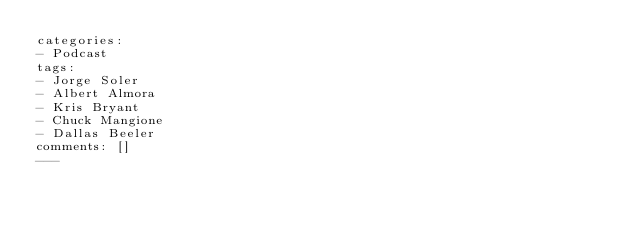<code> <loc_0><loc_0><loc_500><loc_500><_HTML_>categories:
- Podcast
tags:
- Jorge Soler
- Albert Almora
- Kris Bryant
- Chuck Mangione
- Dallas Beeler
comments: []
---</code> 